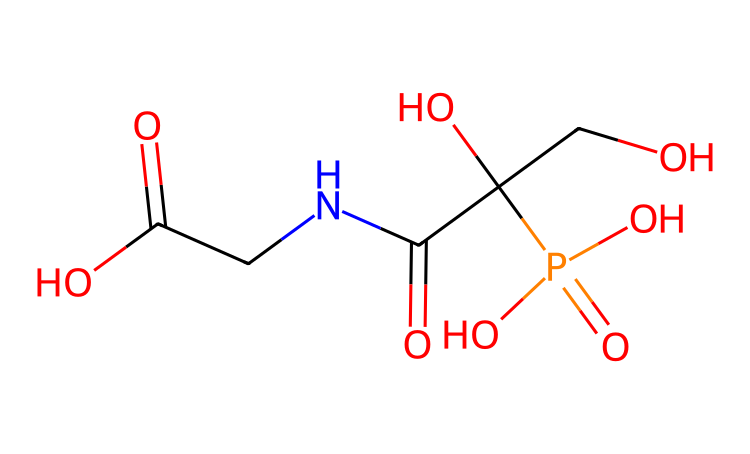What is the main functional group present in glyphosate? The structure includes the -PO₄ group, which is characteristic of phosphonic acids, indicating that glyphosate has a phosphorus-containing functional group.
Answer: phosphonate How many carbon atoms are in the glyphosate structure? By analyzing the SMILES representation, there are five carbon atoms identified in the structure.
Answer: five What is the total number of oxygen atoms in glyphosate? The molecule has a total of four oxygen atoms, counted from both the -PO₄ group and the carbonyl and hydroxyl groups present in the structure.
Answer: four What does the presence of the phosphorus atom indicate about glyphosate? The inclusion of phosphorus signifies that glyphosate is a phosphorus-containing herbicide, which is important for its activity as an herbicide affecting amino acid synthesis in plants.
Answer: herbicide How many different types of functional groups are present in glyphosate? The molecule features multiple functional groups: hydroxyl (-OH), amine (-NH), and the phosphonate group (-PO₄), showing that it has at least three different types of functional groups.
Answer: three 